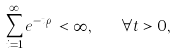<formula> <loc_0><loc_0><loc_500><loc_500>\sum _ { i = 1 } ^ { \infty } e ^ { - t \rho _ { i } } < \infty , \quad \forall t > 0 ,</formula> 